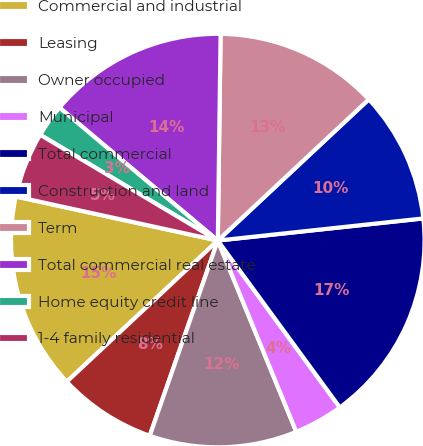Convert chart. <chart><loc_0><loc_0><loc_500><loc_500><pie_chart><fcel>Commercial and industrial<fcel>Leasing<fcel>Owner occupied<fcel>Municipal<fcel>Total commercial<fcel>Construction and land<fcel>Term<fcel>Total commercial real estate<fcel>Home equity credit line<fcel>1-4 family residential<nl><fcel>15.38%<fcel>7.7%<fcel>11.54%<fcel>3.85%<fcel>16.66%<fcel>10.26%<fcel>12.82%<fcel>14.1%<fcel>2.57%<fcel>5.13%<nl></chart> 